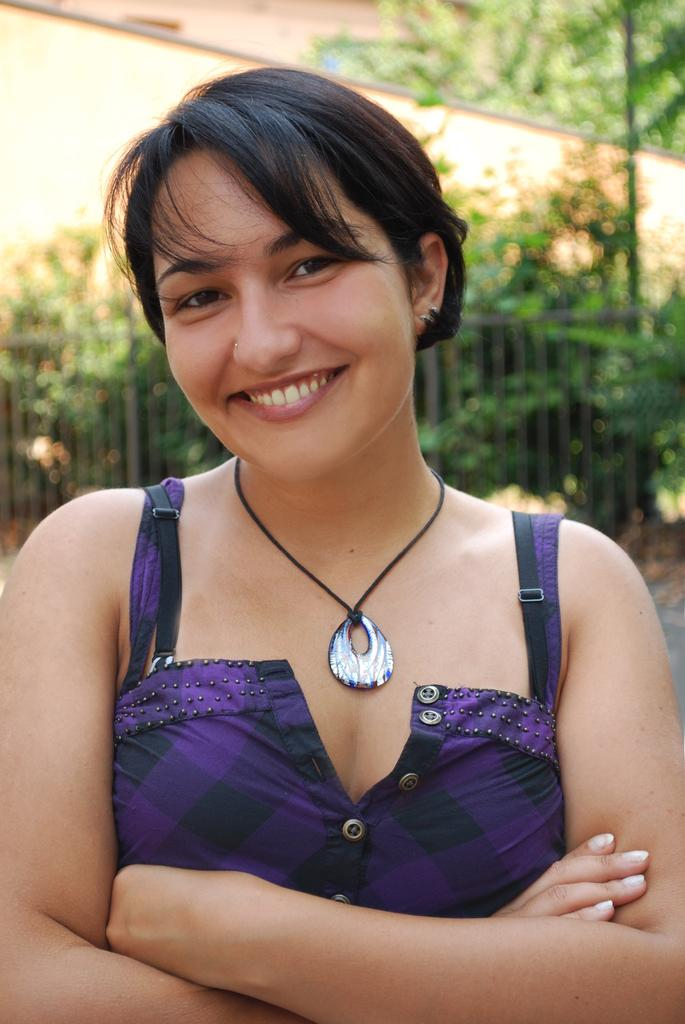Who is present in the image? There is a woman in the image. What is the woman wearing in the image? The woman is wearing a necklace in the image. What can be seen in the background of the image? There are trees and a clear sky visible in the background of the image. How is the background of the image depicted? The background of the image is slightly blurred. What type of sweater is the woman wearing in the image? The provided facts do not mention a sweater; the woman is only described as wearing a necklace. What kind of watch can be seen on the woman's wrist in the image? There is no mention of a watch in the provided facts; the woman is only described as wearing a necklace. 